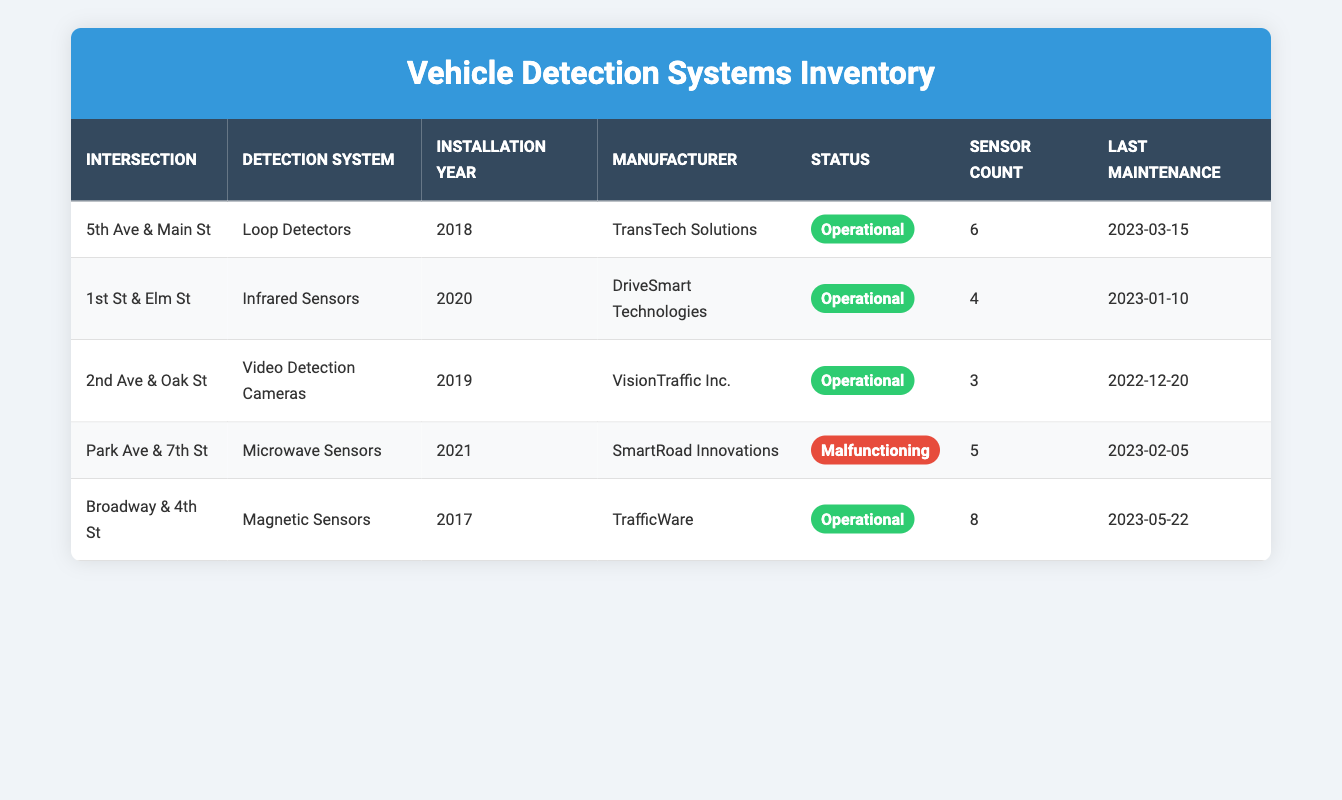What detection system is installed at 5th Ave & Main St? According to the table, at 5th Ave & Main St, the detection system installed is Loop Detectors.
Answer: Loop Detectors Which intersection has the highest number of sensors? By examining the sensor count across all intersections, Broadway & 4th St has the highest count with 8 sensors.
Answer: Broadway & 4th St How many intersections have malfunctioning detection systems? The table shows 5 intersections total, and only 1 intersection, Park Ave & 7th St, has a malfunctioning detection system.
Answer: 1 Is the Microwave Sensors system operational? Looking at the status column, the Microwave Sensors installed at Park Ave & 7th St is labeled as malfunctioning, which means it is not operational.
Answer: No What is the average installation year of the detection systems? The installation years listed are 2018, 2020, 2019, 2021, and 2017. Their sum is 2018 + 2020 + 2019 + 2021 + 2017 = 10095, and there are 5 systems, so the average installation year is 10095 / 5 = 2019.
Answer: 2019 Which manufacturer has the most detection systems installed? Counting unique manufacturers, TransTech Solutions has 1 system, DriveSmart Technologies has 1, VisionTraffic Inc. has 1, SmartRoad Innovations has 1, and TrafficWare has 1. No manufacturer has more than one system, so the count is equal.
Answer: None (all manufacturers have 1 system each) What is the last maintenance date for Loop Detectors? The last maintenance date for Loop Detectors at 5th Ave & Main St, as seen in the table, is 2023-03-15.
Answer: 2023-03-15 Are there any Video Detection Cameras installed at intersections? The table indicates that there is indeed a system of Video Detection Cameras installed at 2nd Ave & Oak St, confirming the presence of this type of sensor.
Answer: Yes What is the total count of sensors installed across all intersections? To find the total, we add the sensor counts: 6 (5th Ave) + 4 (1st St) + 3 (2nd Ave) + 5 (Park Ave) + 8 (Broadway) = 26 sensors in total.
Answer: 26 